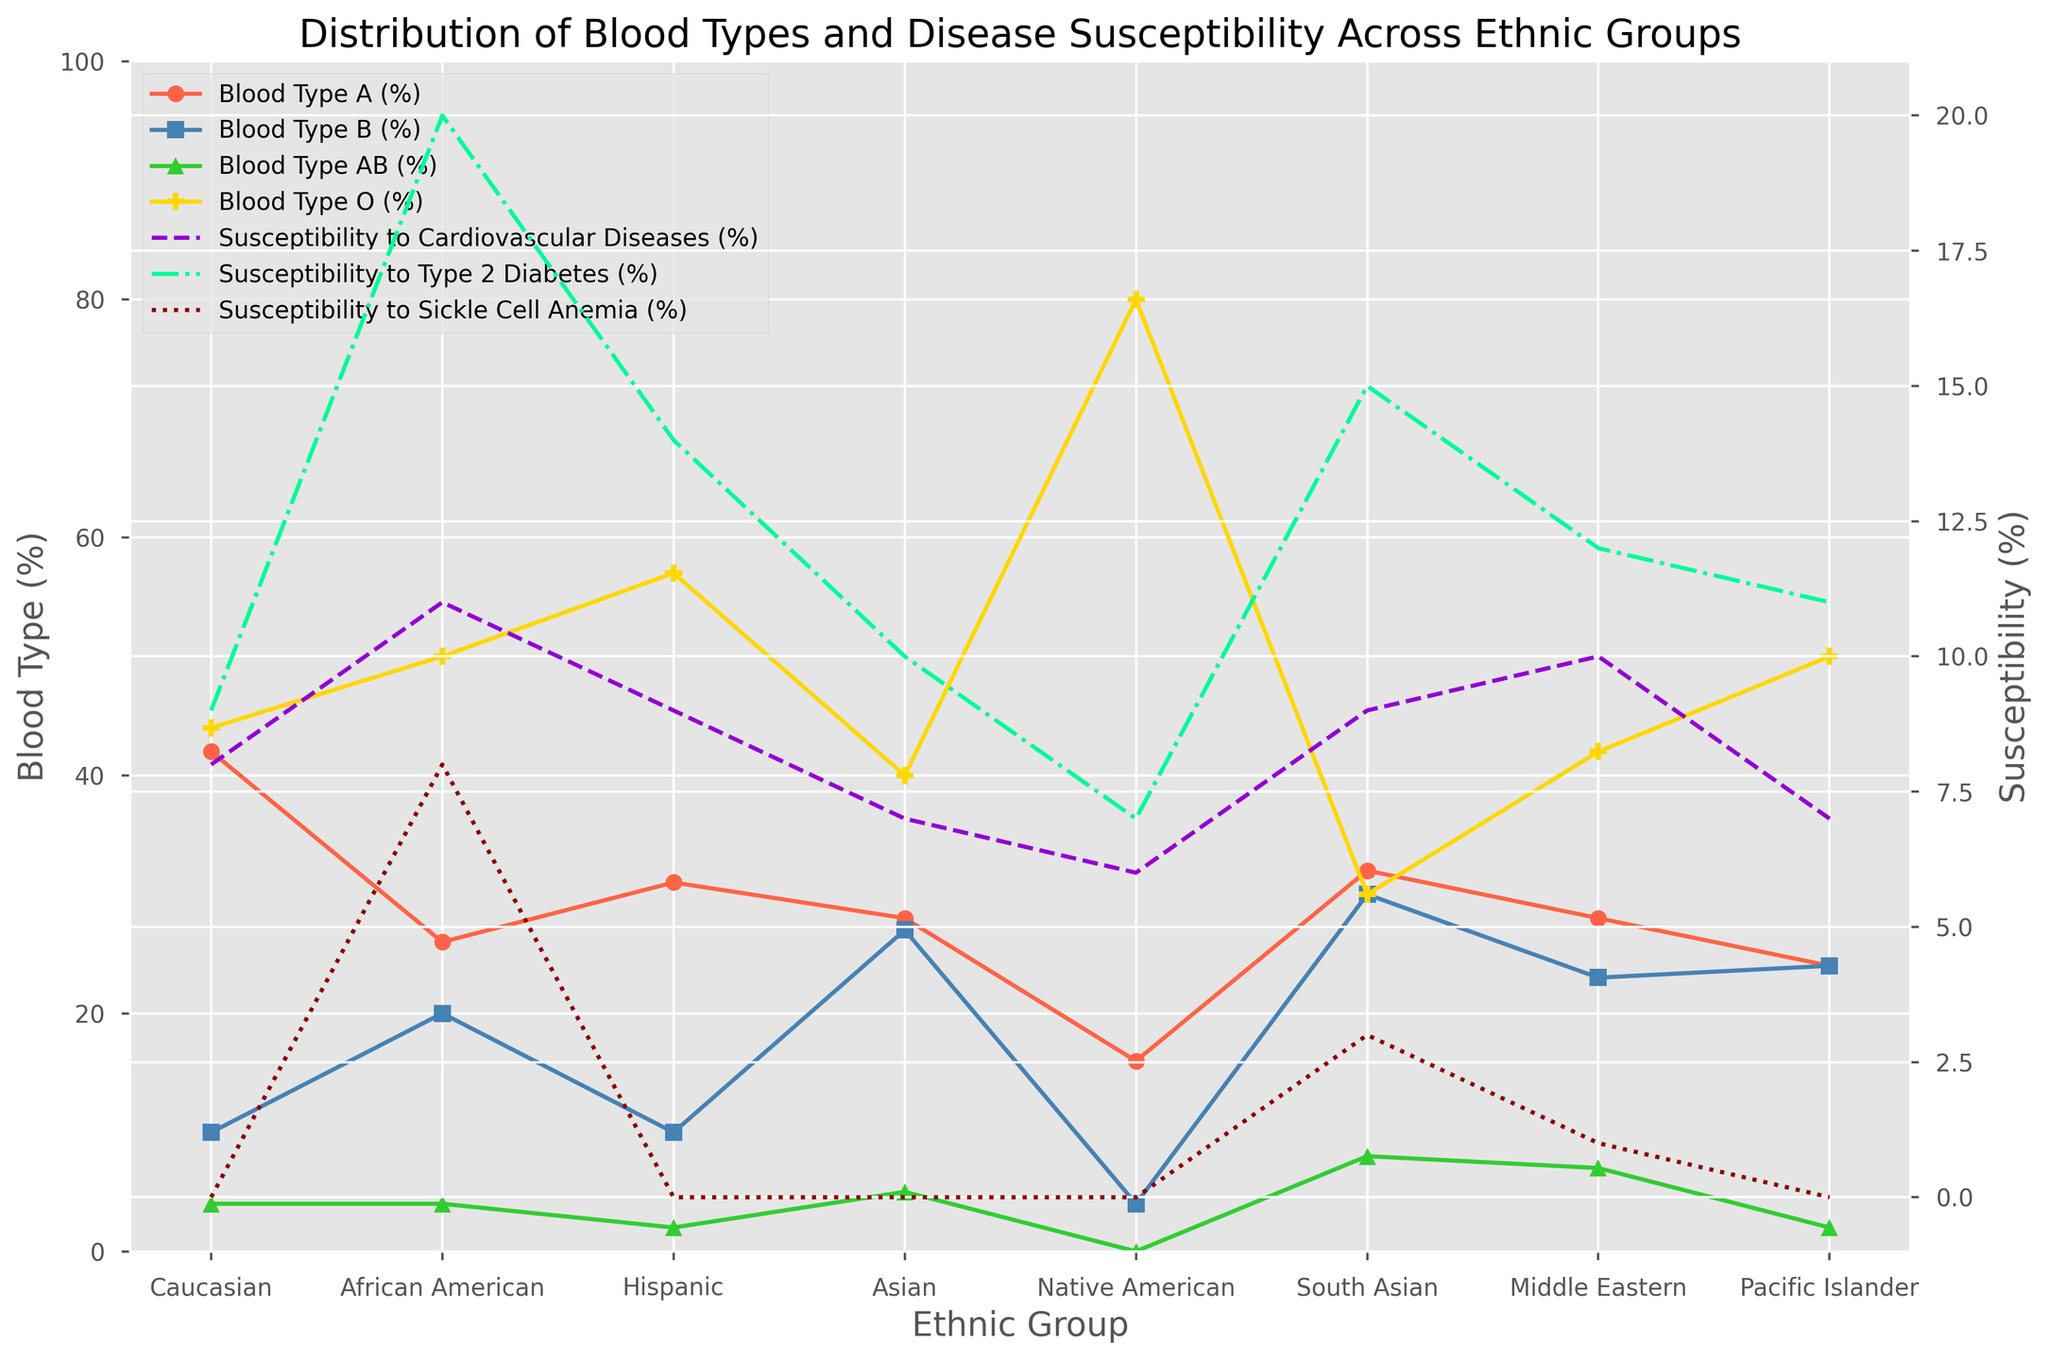what's the average percentage of Blood Type B across all ethnic groups? First, locate the percentages of Blood Type B for all ethnic groups. The percentages are: 10, 20, 10, 27, 4, 30, 23, 24. Sum these up: 10 + 20 + 10 + 27 + 4 + 30 + 23 + 24 = 148. Then, divide by the number of data points: 148 / 8 = 18.5.
Answer: 18.5 which ethnic group has the highest susceptibility to Type 2 Diabetes? Find the values corresponding to "Susceptibility to Type 2 Diabetes (%)" for all ethnic groups. The percentages are: 9, 20, 14, 10, 7, 15, 12, 11. Notice that African American has the highest value at 20%.
Answer: African American are there any ethnic groups with equal percentages of Blood Type AB and O? Compare the percentages of Blood Type AB and Blood Type O for each ethnic group. Analyze the data: Caucasian (4 vs 44), African American (4 vs 50), Hispanic (2 vs 57), Asian (5 vs 40), Native American (0 vs 80), South Asian (8 vs 30), Middle Eastern (7 vs 42), Pacific Islander (2 vs 50). There are no ethnic groups with equal percentages for Blood Type AB and O.
Answer: No which disease has the most uniform susceptibility across ethnic groups? Look at the lines representing susceptibility to different diseases and observe their uniformity across the ethnic groups. The lines for "Cardiovascular Diseases," "Type 2 Diabetes," and "Sickle Cell Anemia" show that "Susceptibility to Cardiovascular Diseases" remains relatively consistent across all ethnic groups compared to the others.
Answer: Cardiovascular Diseases what's the range of Blood Type O percentages across all ethnic groups? Locate the percentages of Blood Type O for all ethnic groups: 44, 50, 57, 40, 80, 30, 42, 50. The minimum value is 30 (South Asian), and the maximum value is 80 (Native American). The range is 80 - 30 = 50.
Answer: 50 which two ethnic groups have no susceptibility to Sickle Cell Anemia? Identify the values of "Susceptibility to Sickle Cell Anemia (%)" for all ethnic groups: 0, 8, 0, 0, 0, 3, 1, 0. Caucasian, Hispanic, Asian, Native American, and Pacific Islander have a susceptibility of 0%.
Answer: Caucasian, Hispanic is the susceptibility to Cardiovascular Diseases higher for Middle Eastern or South Asian ethnic group? Compare the values for "Susceptibility to Cardiovascular Diseases (%)". For Middle Eastern, it is 10%, and for South Asian, it is 9%. Consequently, the Middle Eastern group has a higher susceptibility.
Answer: Middle Eastern what's the sum of the percentages of Blood Type A and B for the South Asian ethnic group? Locate the values for Blood Type A and Blood Type B in the South Asian ethnic group. The percentages are 32% and 30%, respectively. Sum these values: 32 + 30 = 62.
Answer: 62 how many ethnic groups have over 50% of Blood Type O? Identify the percentages of Blood Type O for all ethnic groups: 44, 50, 57, 40, 80, 30, 42, 50. Hispanic and Native American ethnic groups have percentages over 50%.
Answer: 2 which ethnic group has the lowest percentage of Blood Type A? Find the values for Blood Type A for all ethnic groups: 42, 26, 31, 28, 16, 32, 28, 24. Native American has the lowest percentage at 16%.
Answer: Native American 